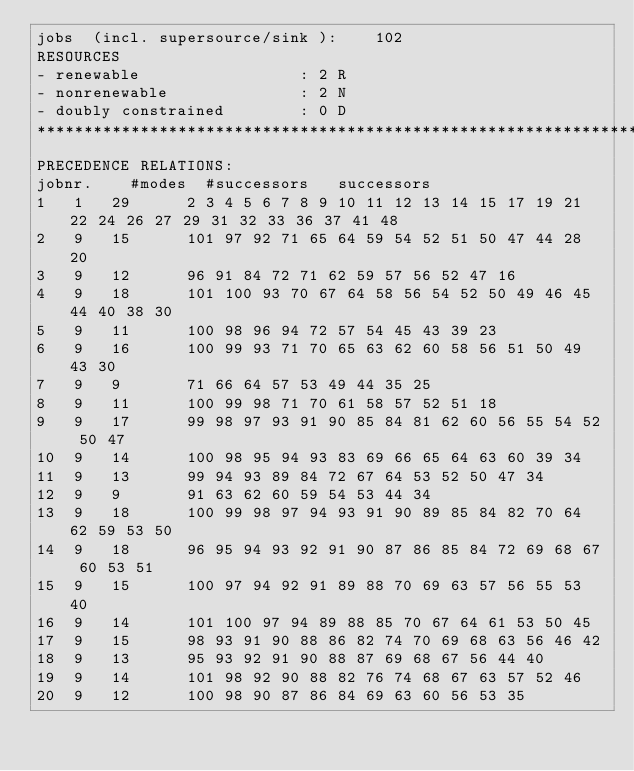<code> <loc_0><loc_0><loc_500><loc_500><_ObjectiveC_>jobs  (incl. supersource/sink ):	102
RESOURCES
- renewable                 : 2 R
- nonrenewable              : 2 N
- doubly constrained        : 0 D
************************************************************************
PRECEDENCE RELATIONS:
jobnr.    #modes  #successors   successors
1	1	29		2 3 4 5 6 7 8 9 10 11 12 13 14 15 17 19 21 22 24 26 27 29 31 32 33 36 37 41 48 
2	9	15		101 97 92 71 65 64 59 54 52 51 50 47 44 28 20 
3	9	12		96 91 84 72 71 62 59 57 56 52 47 16 
4	9	18		101 100 93 70 67 64 58 56 54 52 50 49 46 45 44 40 38 30 
5	9	11		100 98 96 94 72 57 54 45 43 39 23 
6	9	16		100 99 93 71 70 65 63 62 60 58 56 51 50 49 43 30 
7	9	9		71 66 64 57 53 49 44 35 25 
8	9	11		100 99 98 71 70 61 58 57 52 51 18 
9	9	17		99 98 97 93 91 90 85 84 81 62 60 56 55 54 52 50 47 
10	9	14		100 98 95 94 93 83 69 66 65 64 63 60 39 34 
11	9	13		99 94 93 89 84 72 67 64 53 52 50 47 34 
12	9	9		91 63 62 60 59 54 53 44 34 
13	9	18		100 99 98 97 94 93 91 90 89 85 84 82 70 64 62 59 53 50 
14	9	18		96 95 94 93 92 91 90 87 86 85 84 72 69 68 67 60 53 51 
15	9	15		100 97 94 92 91 89 88 70 69 63 57 56 55 53 40 
16	9	14		101 100 97 94 89 88 85 70 67 64 61 53 50 45 
17	9	15		98 93 91 90 88 86 82 74 70 69 68 63 56 46 42 
18	9	13		95 93 92 91 90 88 87 69 68 67 56 44 40 
19	9	14		101 98 92 90 88 82 76 74 68 67 63 57 52 46 
20	9	12		100 98 90 87 86 84 69 63 60 56 53 35 </code> 